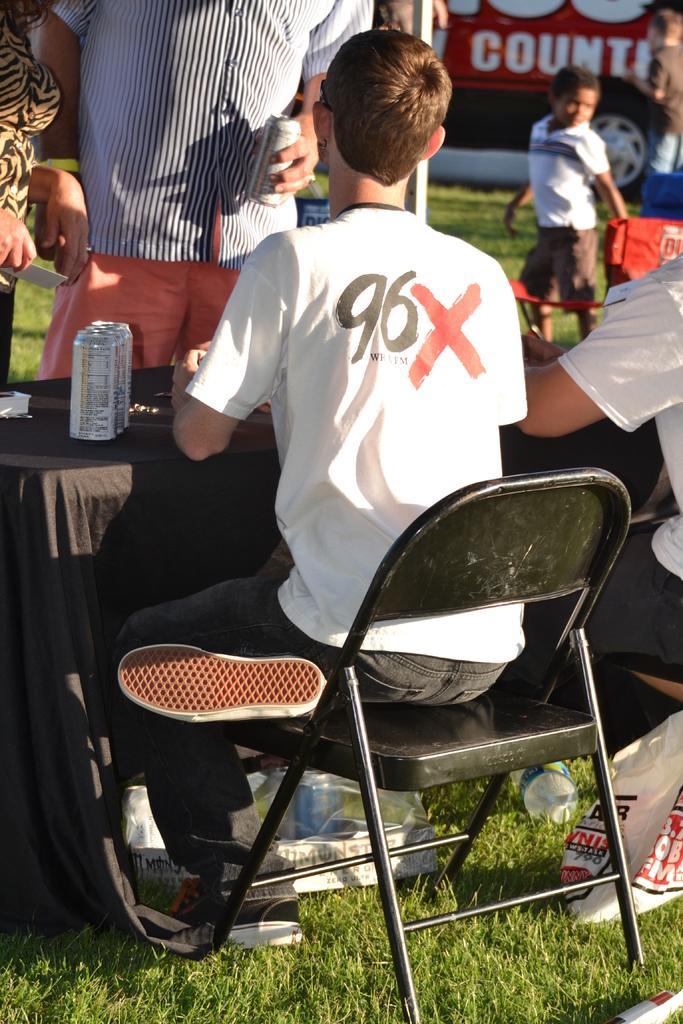In one or two sentences, can you explain what this image depicts? Here we can see 2 persons sitting on the chair,under the chair there is a plastic cover. On the left there is a woman beside her there is a man holding tiny bottle in his hand. On the table we can find few tin bottles. On the left there is a kid standing. In the background we can see a vehicle. 